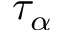Convert formula to latex. <formula><loc_0><loc_0><loc_500><loc_500>\tau _ { \alpha }</formula> 